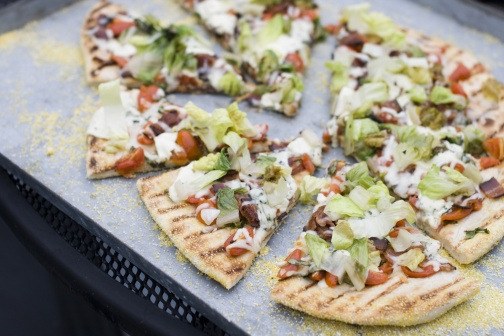What's happening in the scene? The scene depicts a mouth-watering pizza meticulously cut into eight slices and positioned on a textured black tray. The crust exhibits a delightful golden-brown hue, signifying it has been perfectly baked. Vibrant toppings such as crisp lettuce, juicy tomatoes, and melted cheese provide a colorful and appetizing contrast. The fresh, green lettuce is sprinkled generously over the pizza, while the red of the tomatoes complements the verdant foliage. The cheese is melted and evenly distributed, cohesively binding the toppings. The circular arrangement on the tray enhances the visual appeal, with each slice fanning out from the center similar to spokes on a wheel. The image is void of any text or additional objects, spotlighting the pizza's inviting display. This portrayal emphasizes the pizza's rich textures and vivid colors, making it the focal point of the scene. 